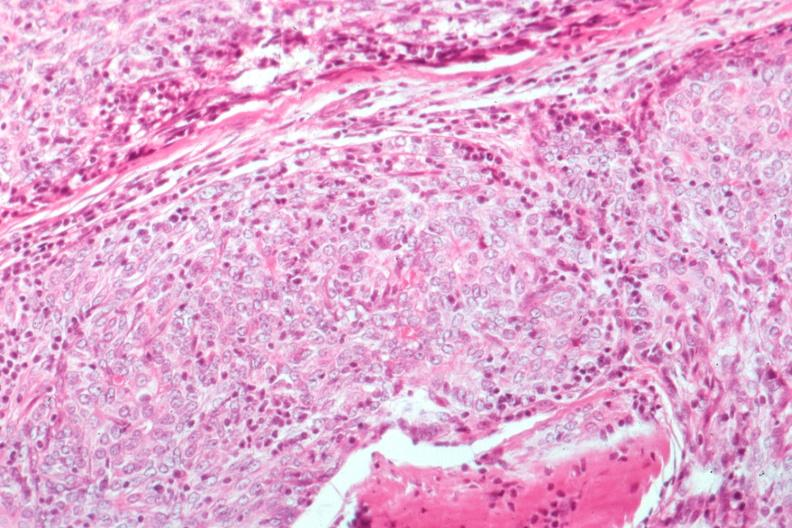s lateral view present?
Answer the question using a single word or phrase. No 